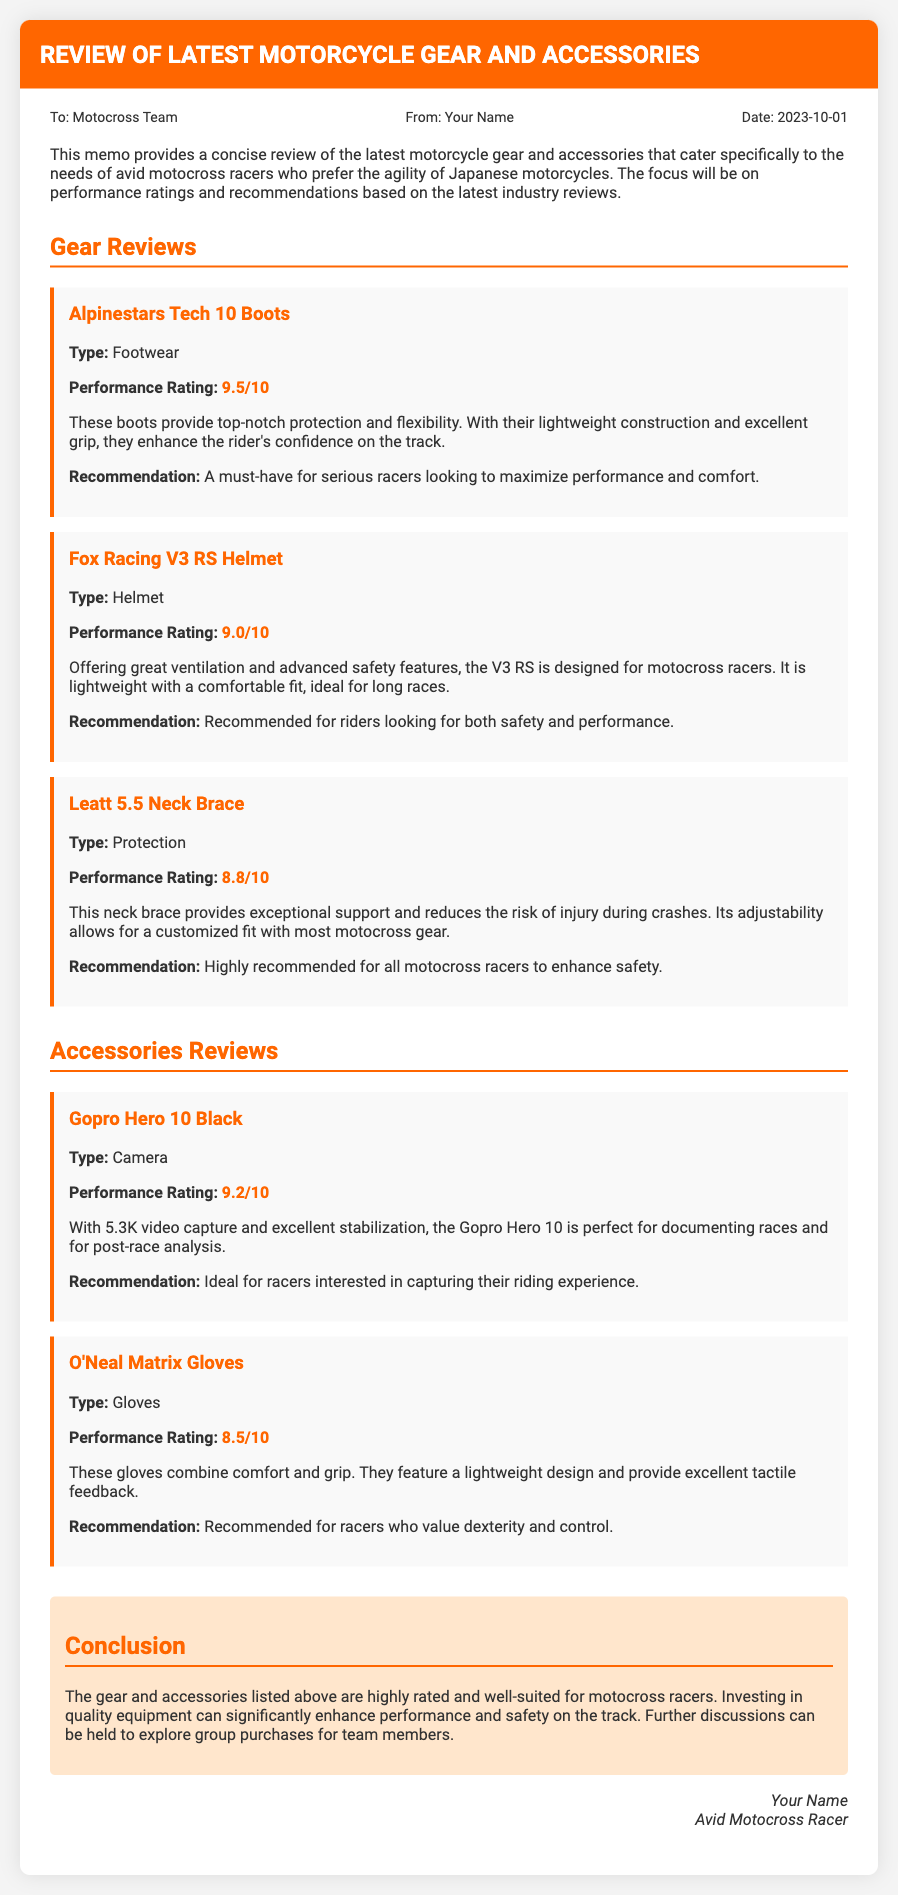What is the performance rating of Alpinestars Tech 10 Boots? The performance rating of Alpinestars Tech 10 Boots is indicated in the memo as 9.5/10.
Answer: 9.5/10 What type of product is the Fox Racing V3 RS? The memo specifies that the Fox Racing V3 RS is a helmet, as stated in the product description.
Answer: Helmet What is the recommendation for the Leatt 5.5 Neck Brace? The memo recommends the Leatt 5.5 Neck Brace as “highly recommended for all motocross racers to enhance safety.”
Answer: Highly recommended for all motocross racers to enhance safety Who is the memo addressed to? The memo is addressed to the Motocross Team, as noted in the recipient section.
Answer: Motocross Team What is the performance rating of the GoPro Hero 10 Black? The performance rating of the GoPro Hero 10 Black is mentioned as 9.2/10 in the document.
Answer: 9.2/10 Which product is recommended for riders looking for comfort and grip? The O'Neal Matrix Gloves are specifically recommended for racers who value dexterity and control, as per the document.
Answer: O'Neal Matrix Gloves What date was the memo written? The date of the memo is provided as 2023-10-01 in the metadata section.
Answer: 2023-10-01 What section comes before the Accessories Reviews? The section before Accessories Reviews is titled Gear Reviews, showing the order in the document.
Answer: Gear Reviews 